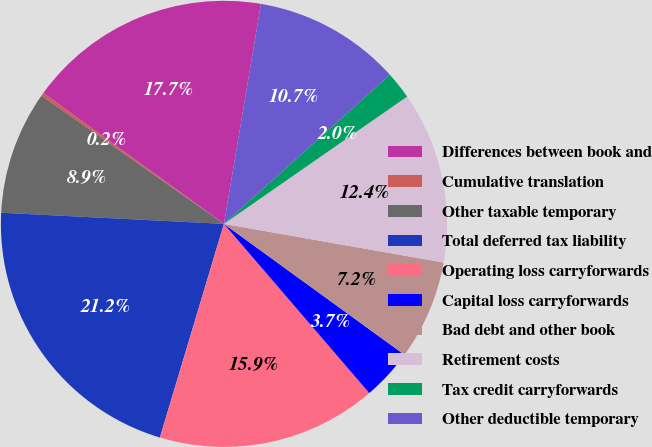Convert chart. <chart><loc_0><loc_0><loc_500><loc_500><pie_chart><fcel>Differences between book and<fcel>Cumulative translation<fcel>Other taxable temporary<fcel>Total deferred tax liability<fcel>Operating loss carryforwards<fcel>Capital loss carryforwards<fcel>Bad debt and other book<fcel>Retirement costs<fcel>Tax credit carryforwards<fcel>Other deductible temporary<nl><fcel>17.68%<fcel>0.23%<fcel>8.95%<fcel>21.16%<fcel>15.93%<fcel>3.72%<fcel>7.21%<fcel>12.44%<fcel>1.98%<fcel>10.7%<nl></chart> 